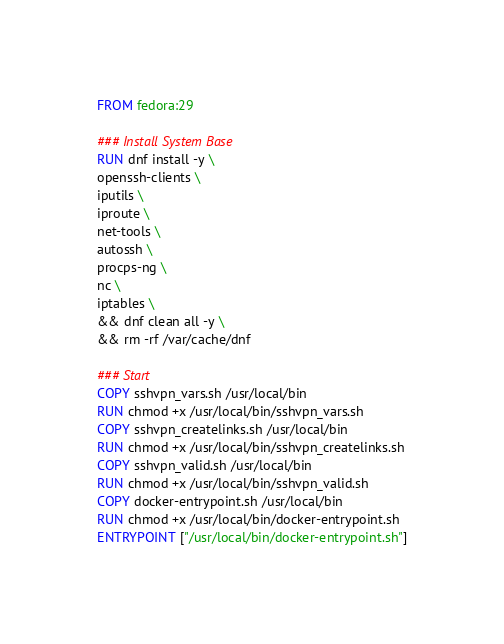Convert code to text. <code><loc_0><loc_0><loc_500><loc_500><_Dockerfile_>FROM fedora:29

### Install System Base
RUN dnf install -y \
openssh-clients \
iputils \
iproute \
net-tools \
autossh \
procps-ng \
nc \
iptables \
&& dnf clean all -y \
&& rm -rf /var/cache/dnf

### Start
COPY sshvpn_vars.sh /usr/local/bin
RUN chmod +x /usr/local/bin/sshvpn_vars.sh
COPY sshvpn_createlinks.sh /usr/local/bin
RUN chmod +x /usr/local/bin/sshvpn_createlinks.sh
COPY sshvpn_valid.sh /usr/local/bin
RUN chmod +x /usr/local/bin/sshvpn_valid.sh
COPY docker-entrypoint.sh /usr/local/bin
RUN chmod +x /usr/local/bin/docker-entrypoint.sh
ENTRYPOINT ["/usr/local/bin/docker-entrypoint.sh"]
</code> 